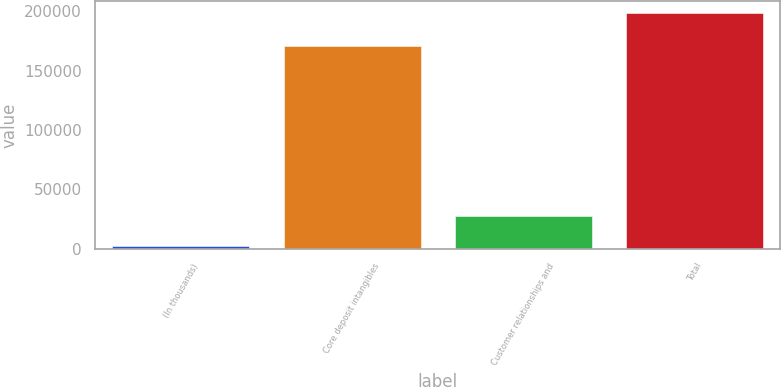Convert chart. <chart><loc_0><loc_0><loc_500><loc_500><bar_chart><fcel>(In thousands)<fcel>Core deposit intangibles<fcel>Customer relationships and<fcel>Total<nl><fcel>2014<fcel>170688<fcel>28014<fcel>198702<nl></chart> 